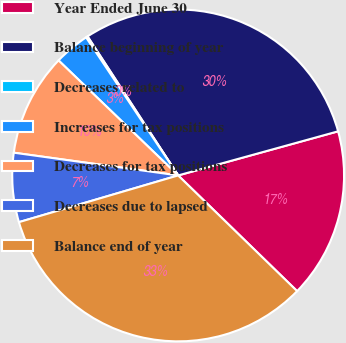Convert chart. <chart><loc_0><loc_0><loc_500><loc_500><pie_chart><fcel>Year Ended June 30<fcel>Balance beginning of year<fcel>Decreases related to<fcel>Increases for tax positions<fcel>Decreases for tax positions<fcel>Decreases due to lapsed<fcel>Balance end of year<nl><fcel>16.56%<fcel>29.91%<fcel>0.17%<fcel>3.45%<fcel>10.0%<fcel>6.73%<fcel>33.18%<nl></chart> 